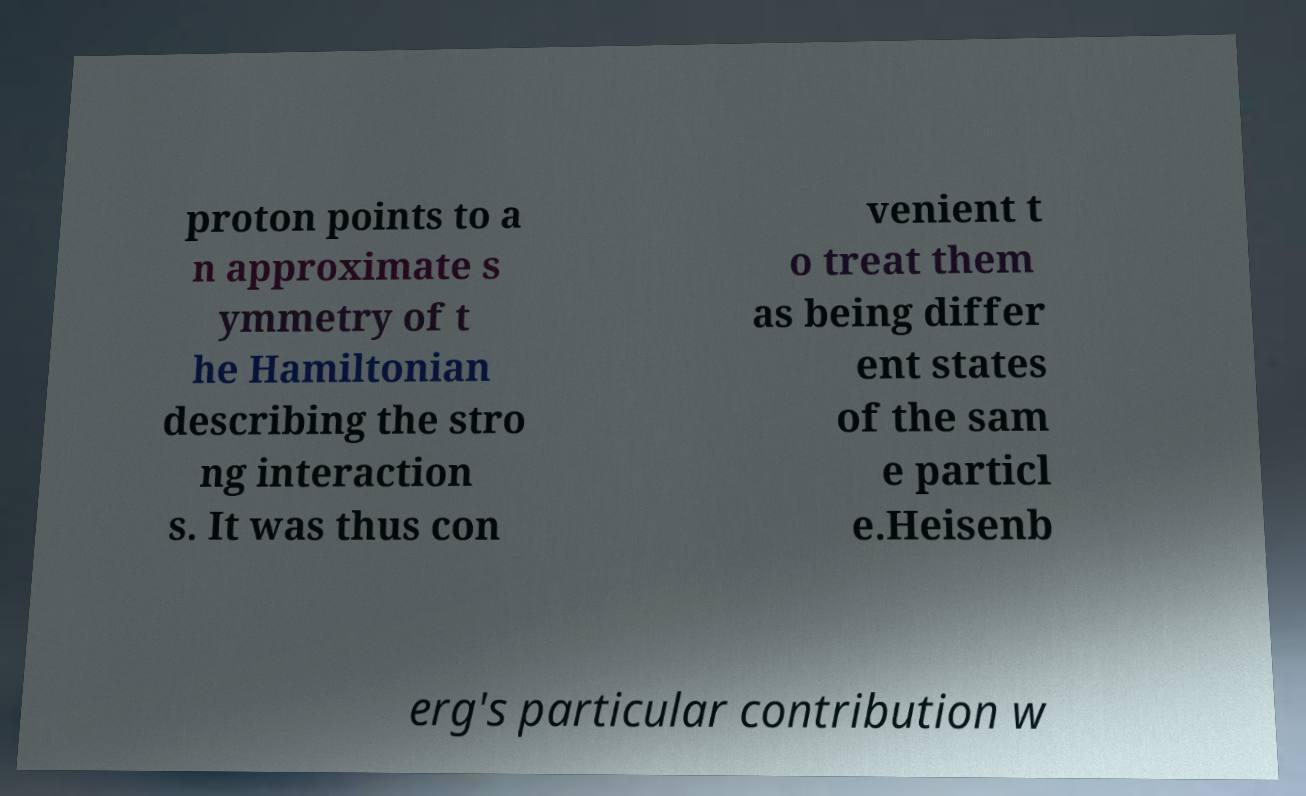Can you accurately transcribe the text from the provided image for me? proton points to a n approximate s ymmetry of t he Hamiltonian describing the stro ng interaction s. It was thus con venient t o treat them as being differ ent states of the sam e particl e.Heisenb erg's particular contribution w 